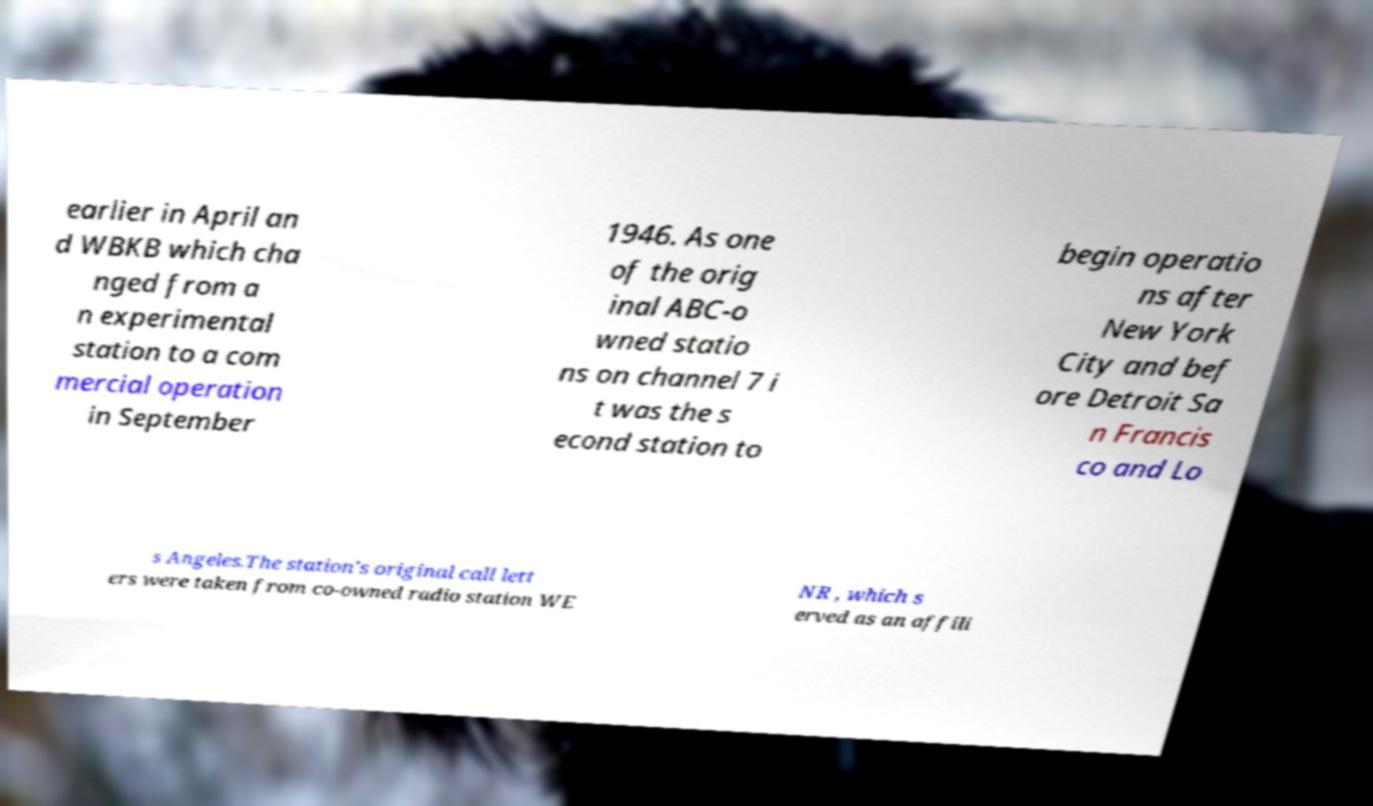Could you extract and type out the text from this image? earlier in April an d WBKB which cha nged from a n experimental station to a com mercial operation in September 1946. As one of the orig inal ABC-o wned statio ns on channel 7 i t was the s econd station to begin operatio ns after New York City and bef ore Detroit Sa n Francis co and Lo s Angeles.The station's original call lett ers were taken from co-owned radio station WE NR , which s erved as an affili 